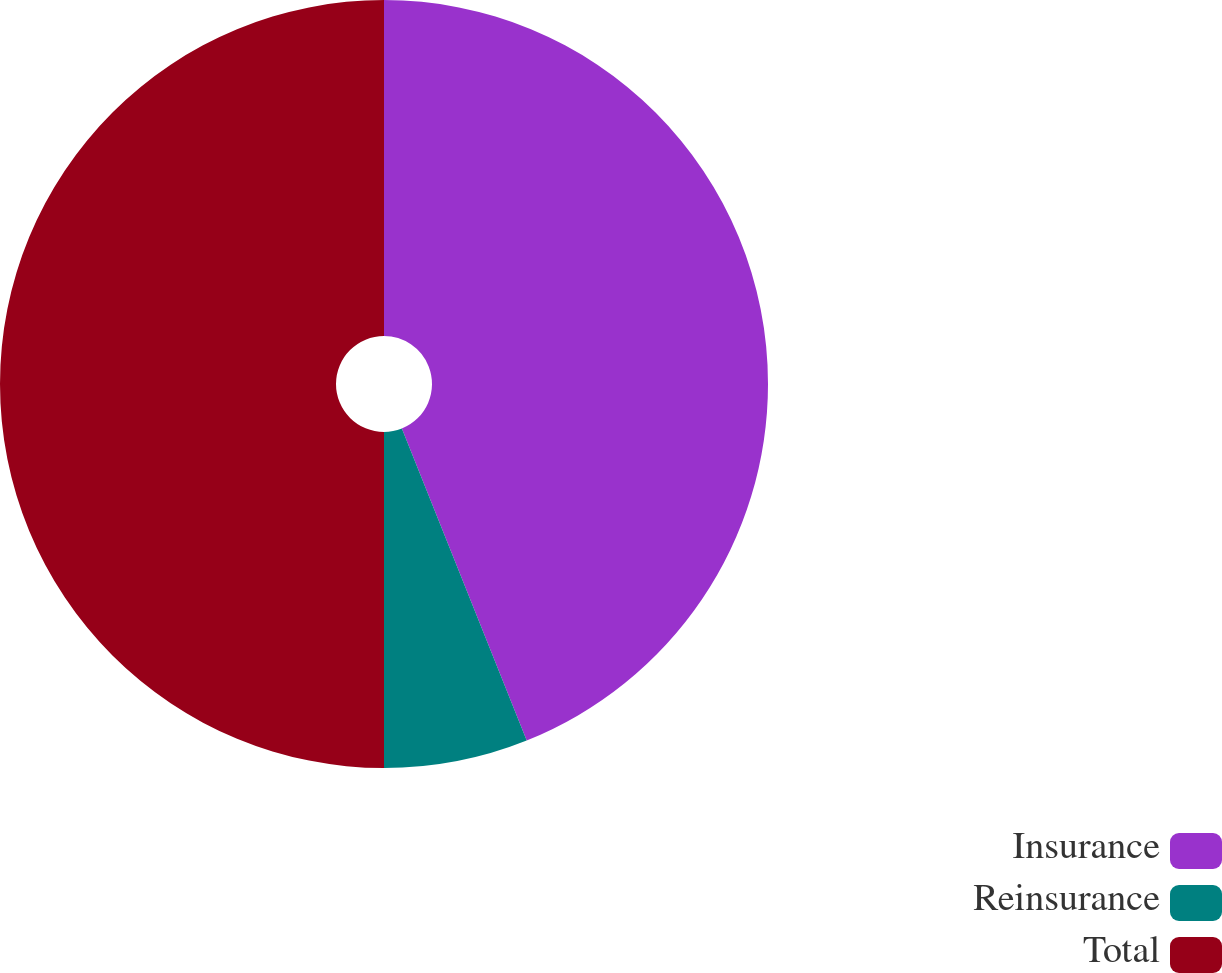<chart> <loc_0><loc_0><loc_500><loc_500><pie_chart><fcel>Insurance<fcel>Reinsurance<fcel>Total<nl><fcel>43.94%<fcel>6.06%<fcel>50.0%<nl></chart> 